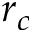<formula> <loc_0><loc_0><loc_500><loc_500>r _ { c }</formula> 